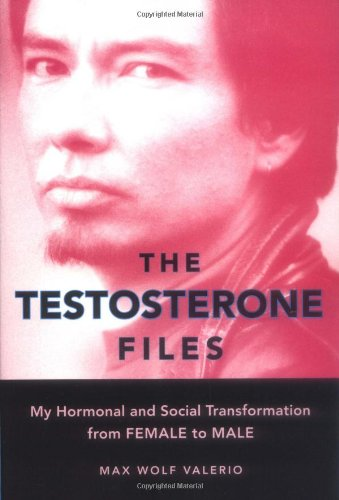How does the author's background influence the narrative in this book? Max Wolf Valerio's background as a poet and activist deeply enriches the narrative, bringing a unique, introspective, and eloquent perspective to the complex issues surrounding gender transition and societal perception. 